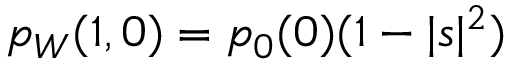Convert formula to latex. <formula><loc_0><loc_0><loc_500><loc_500>p _ { W } ( 1 , 0 ) = p _ { 0 } ( 0 ) ( 1 - | s | ^ { 2 } )</formula> 